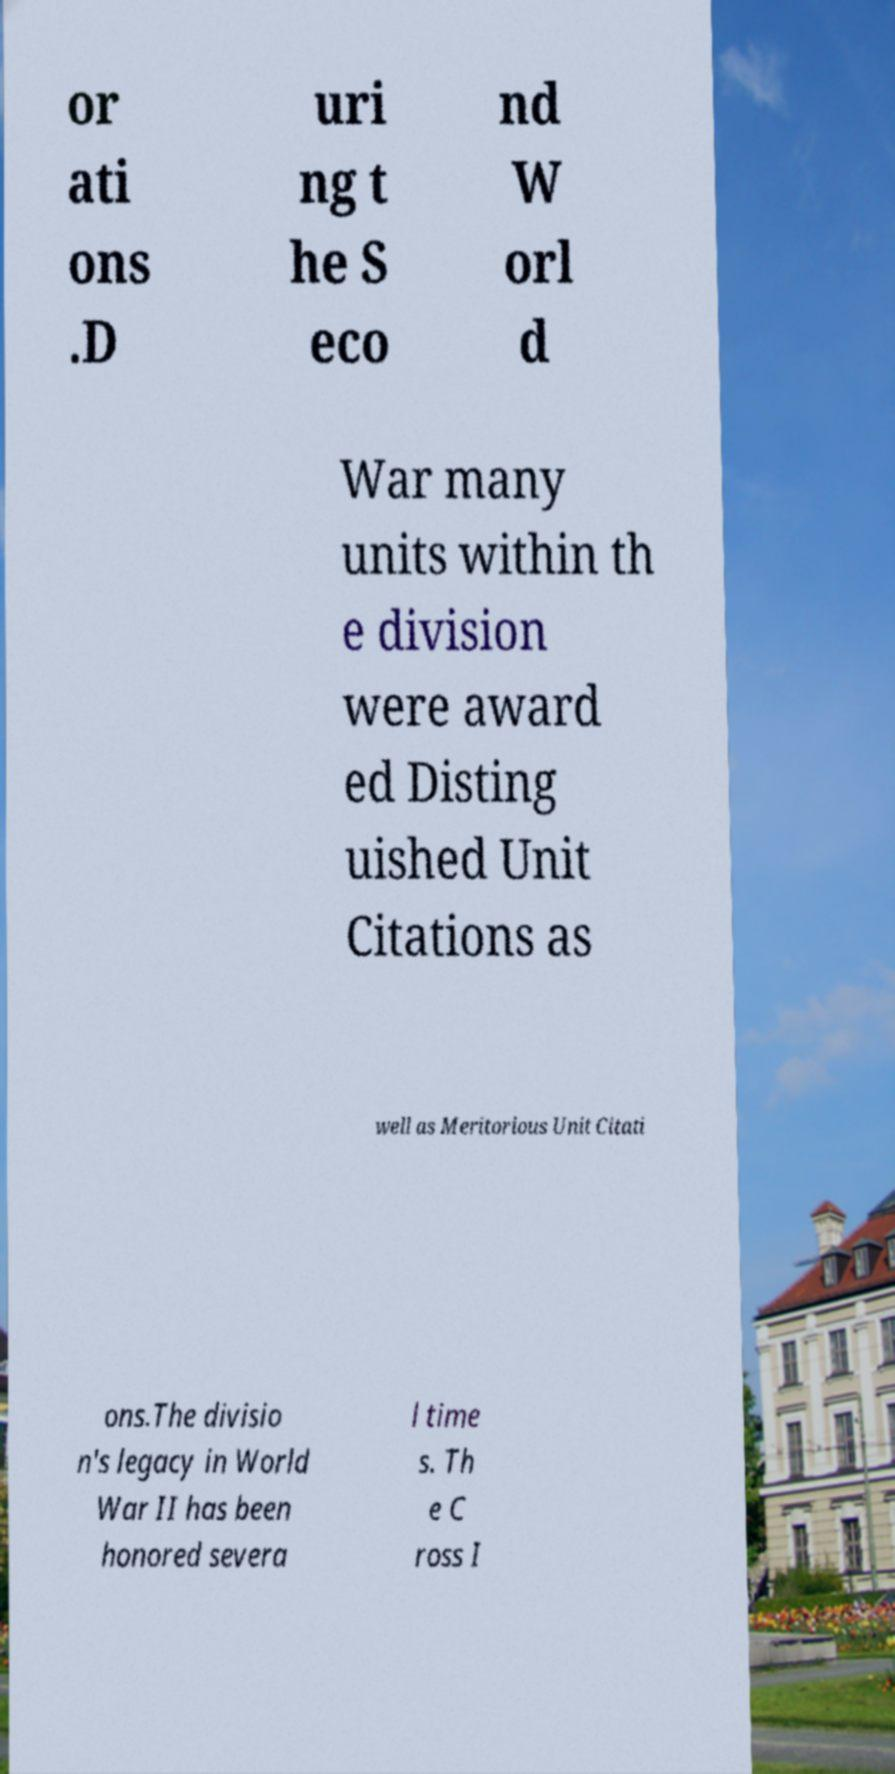There's text embedded in this image that I need extracted. Can you transcribe it verbatim? or ati ons .D uri ng t he S eco nd W orl d War many units within th e division were award ed Disting uished Unit Citations as well as Meritorious Unit Citati ons.The divisio n's legacy in World War II has been honored severa l time s. Th e C ross I 